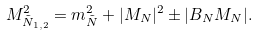<formula> <loc_0><loc_0><loc_500><loc_500>M ^ { 2 } _ { \tilde { N } _ { 1 , 2 } } = m _ { \tilde { N } } ^ { 2 } + | M _ { N } | ^ { 2 } \pm | B _ { N } M _ { N } | .</formula> 